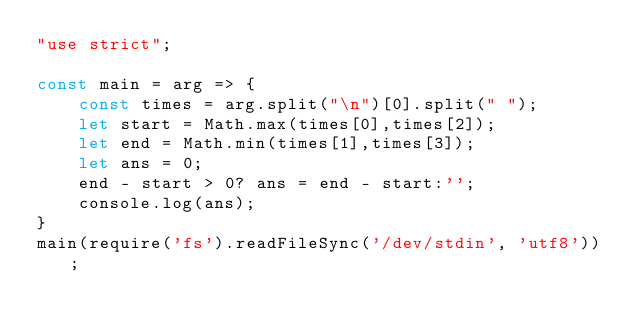Convert code to text. <code><loc_0><loc_0><loc_500><loc_500><_JavaScript_>"use strict";
    
const main = arg => {
    const times = arg.split("\n")[0].split(" ");
  	let start = Math.max(times[0],times[2]);
  	let end = Math.min(times[1],times[3]);
  	let ans = 0;
  	end - start > 0? ans = end - start:'';
    console.log(ans);
}
main(require('fs').readFileSync('/dev/stdin', 'utf8'));
</code> 